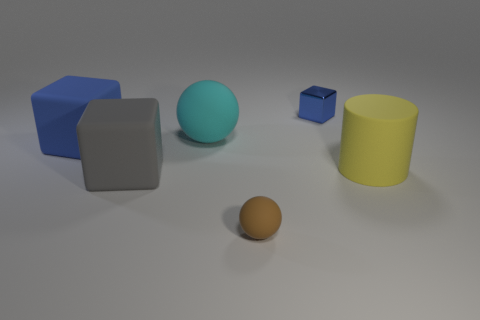Add 1 tiny blue objects. How many objects exist? 7 Subtract all spheres. How many objects are left? 4 Subtract 0 purple cylinders. How many objects are left? 6 Subtract all brown matte balls. Subtract all blue rubber objects. How many objects are left? 4 Add 3 gray blocks. How many gray blocks are left? 4 Add 4 matte spheres. How many matte spheres exist? 6 